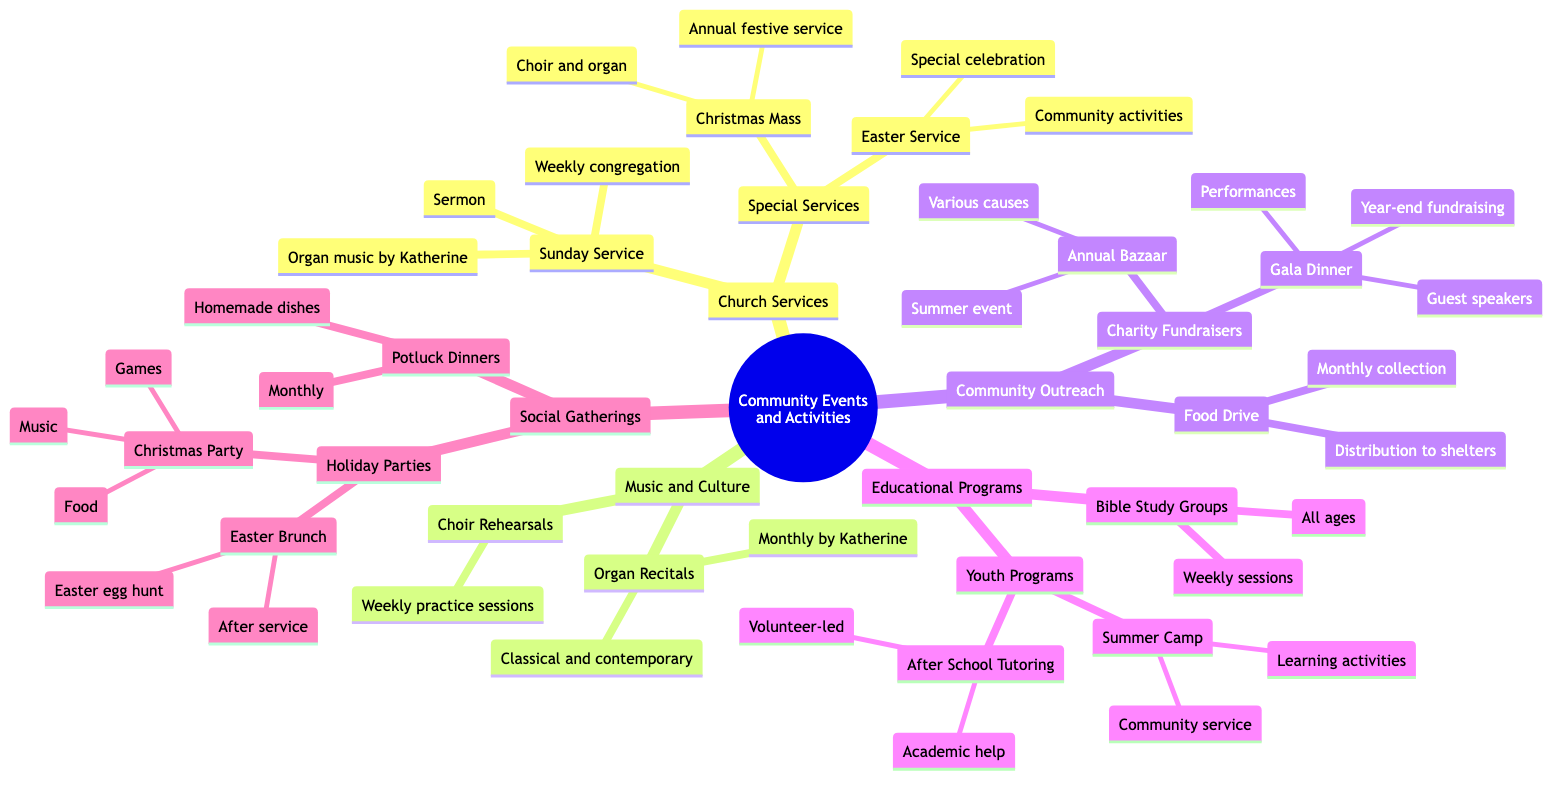What is held every Sunday? The diagram indicates that a Sunday Service is held weekly as a central event in the Church Services category.
Answer: Sunday Service How often do Choir Rehearsals occur? According to the diagram, Choir Rehearsals take place weekly, which is specified under the Music and Culture section.
Answer: Weekly What event features games, food, and music? The diagram points to the Christmas Party within the Social Gatherings category, which includes these elements.
Answer: Christmas Party Which program provides academic help? The After School Tutoring program is designated to provide academic assistance and is categorized under Educational Programs.
Answer: After School Tutoring How many types of Charity Fundraisers are mentioned? By examining the Community Outreach section, there are two specific types of Charity Fundraisers listed: Annual Bazaar and Gala Dinner.
Answer: 2 What type of music is featured in the Organ Recitals? The diagram specifies that the Organ Recitals feature classical and contemporary music, listed under the Music and Culture category.
Answer: Classical and contemporary What is the purpose of the Food Drive? The Food Drive is described as a monthly collection and distribution of food to local shelters, as outlined in Community Outreach.
Answer: Distribution to shelters Which event focuses on community service during summer? The Summer Camp under the Youth Programs emphasizes community service and learning activities, according to the Educational Programs section.
Answer: Summer Camp How many Holiday Parties are mentioned in the diagram? There are two Holiday Parties mentioned: the Christmas Party and the Easter Brunch, both specified under Social Gatherings.
Answer: 2 